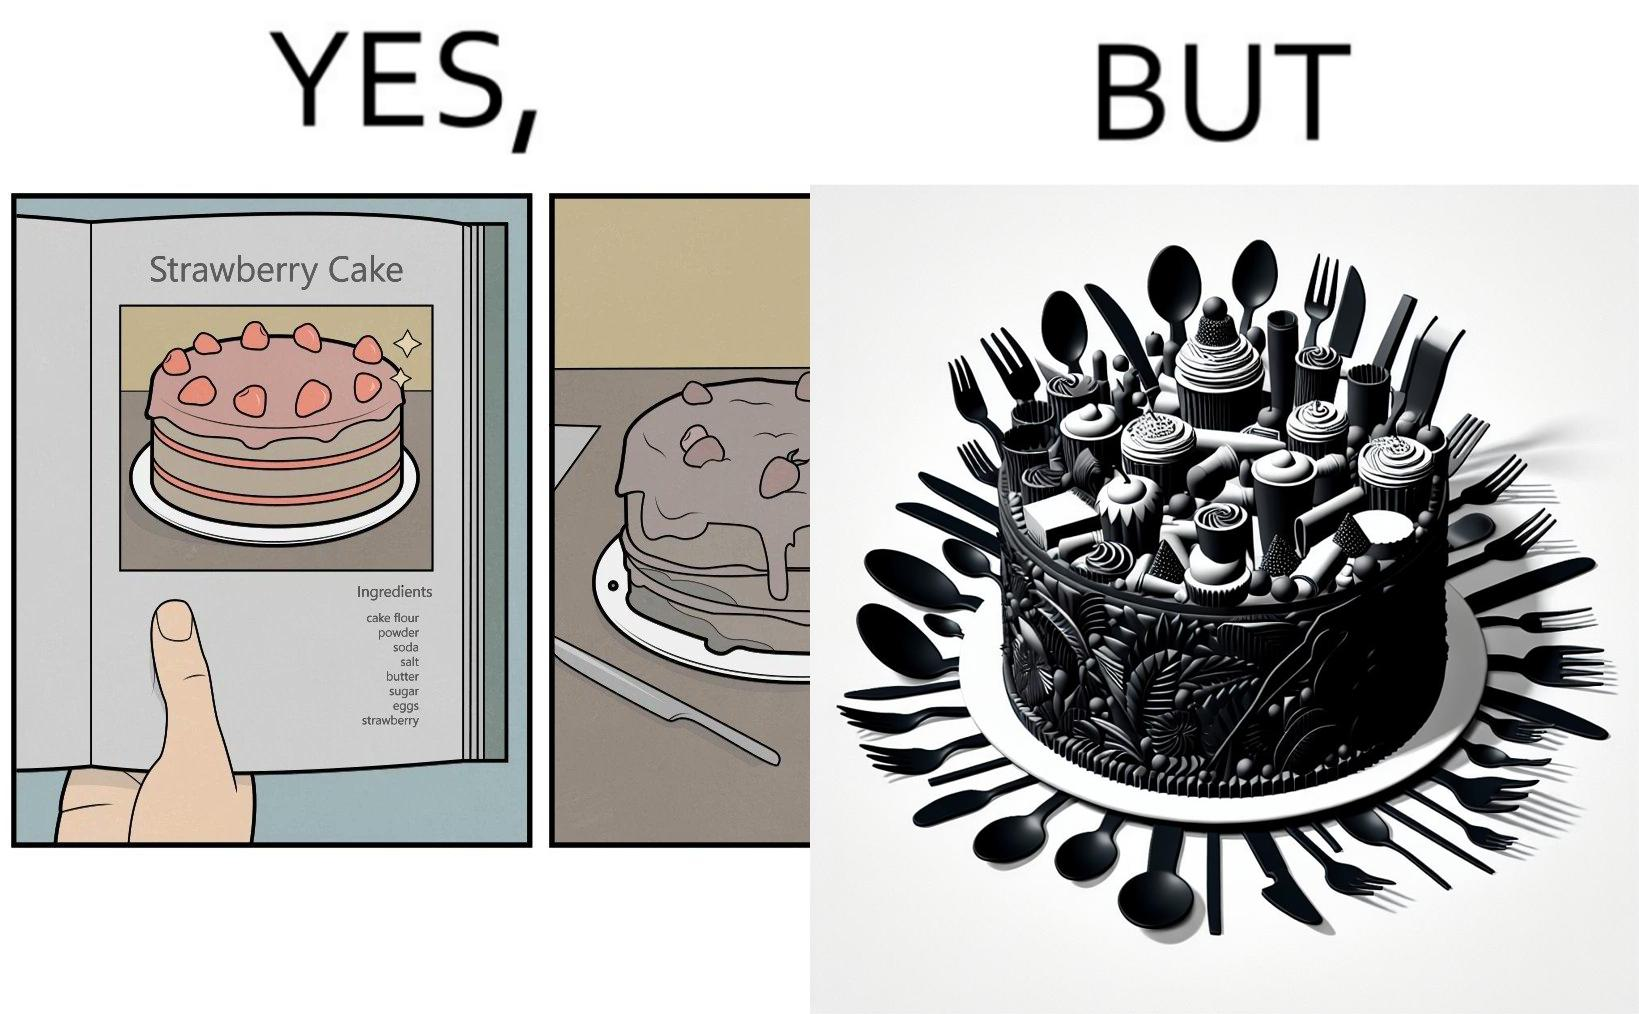Describe the satirical element in this image. The image is funny, as when making a strawberry cake using  a recipe book, the outcome is not quite what is expected, and one has to wash the used utensils afterwards as well. 